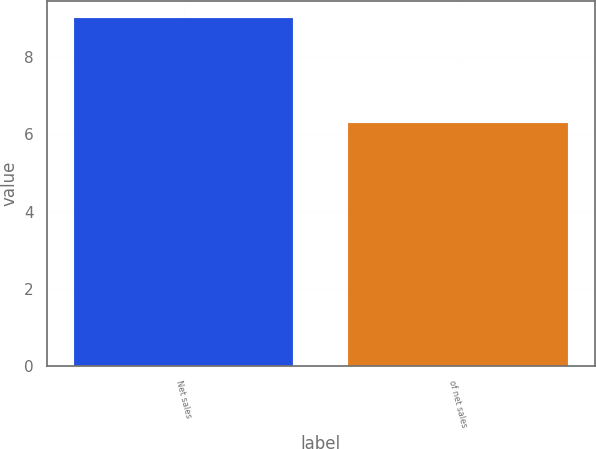Convert chart. <chart><loc_0><loc_0><loc_500><loc_500><bar_chart><fcel>Net sales<fcel>of net sales<nl><fcel>9<fcel>6.3<nl></chart> 